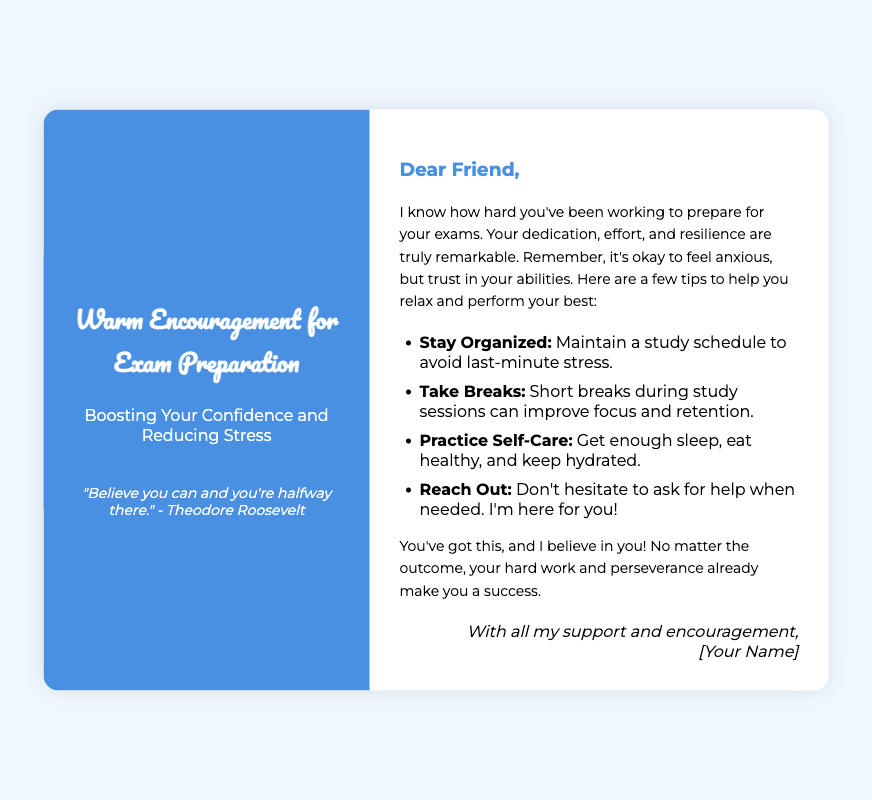What is the title of the greeting card? The title is prominently displayed at the top of the card, providing a statement of encouragement for exam preparation.
Answer: Warm Encouragement for Exam Preparation Who is the quote attributed to? The quote is located in the cover section, serving as a source of motivation for exam preparation.
Answer: Theodore Roosevelt What is one tip mentioned to help reduce stress? This information is part of the list intended to provide strategies for effective study habits and relaxation.
Answer: Take Breaks How many tips are provided in the handwritten message? The tips are listed in a bullet format, which allows for easy counting.
Answer: Four What color is the background of the card? The color is specified at the beginning of the document and affects the overall appearance of the card.
Answer: Blue What does the handwritten message encourage the reader to trust in? This part of the message emphasizes the importance of self-belief and personal effort during exam preparation.
Answer: Abilities What was mentioned as a way to maintain focus during study sessions? The approach to maintaining focus is included in the tips for effective study techniques.
Answer: Short breaks What is the emotional tone of the message inside the card? The tone is conveyed through the language used in the text, indicating support and encouragement.
Answer: Supportive 